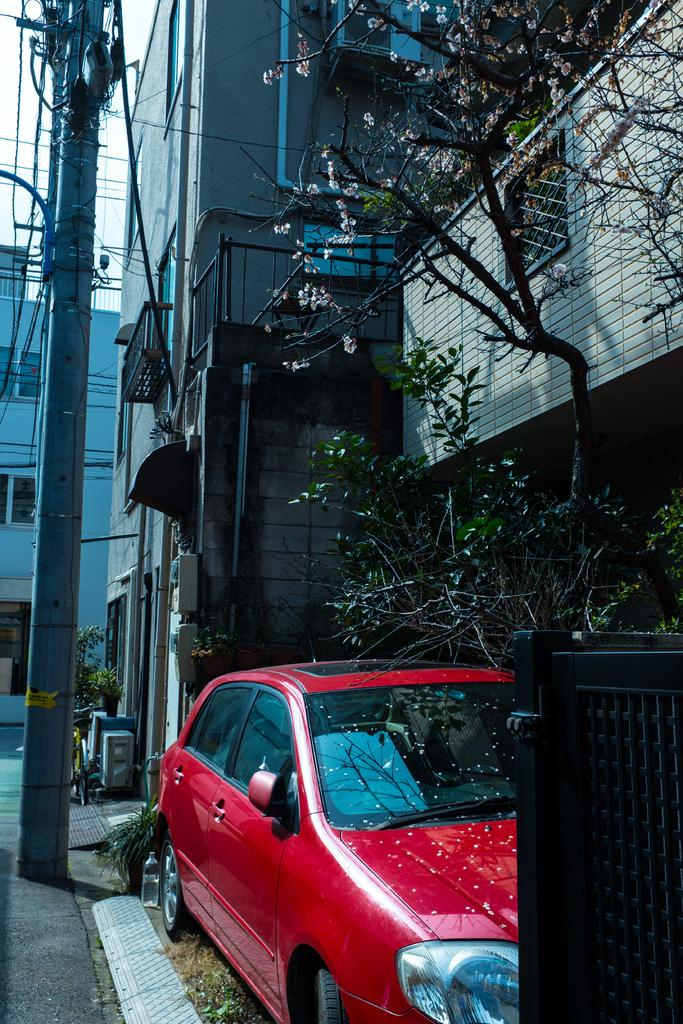What type of structures can be seen in the image? There are buildings in the image. Can you describe the car's location in relation to the tree? The car is beside a tree in the image. Where is the gate located in the image? The gate is in the bottom right of the image. What is on the left side of the image? There is a pole on the left side of the image. Is the porter carrying any luggage near the gate in the image? There is no porter or luggage present in the image. Can you see a stream flowing through the buildings in the image? There is no stream visible in the image; only buildings, a car, a tree, a gate, and a pole are present. 